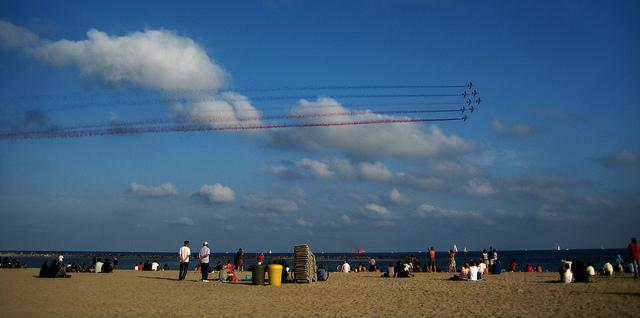How many colors are ejected from the planes flying in formation? Please explain your reasoning. five. There are five different colors extending from the end of the jet engines. 